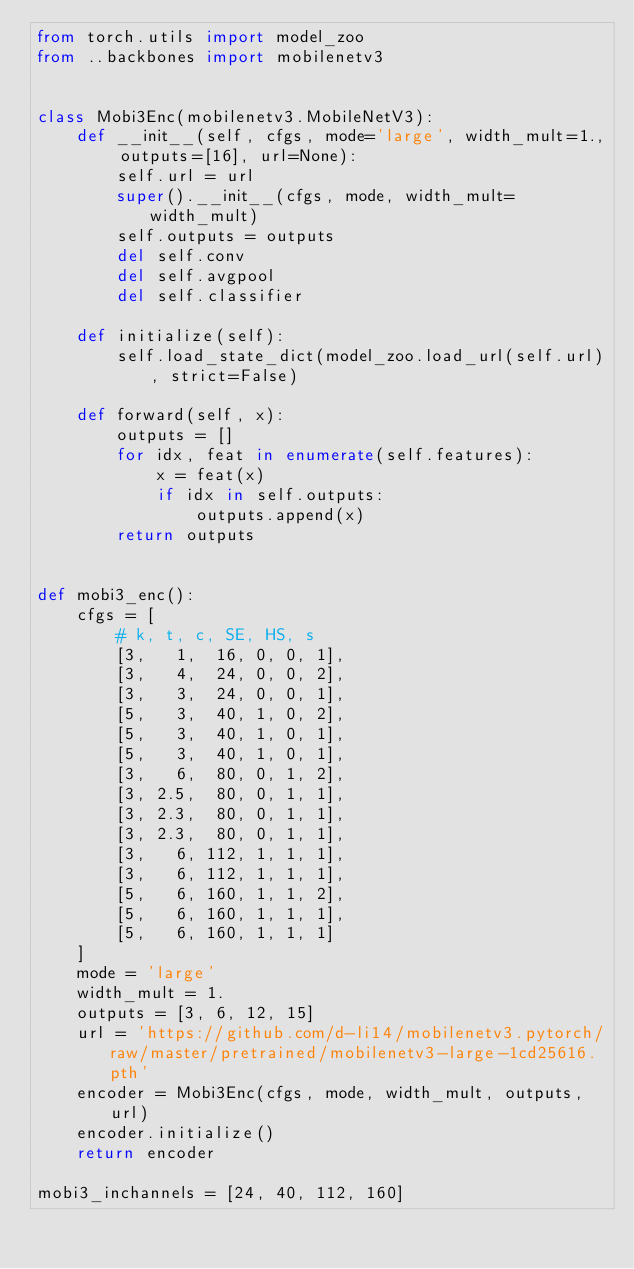Convert code to text. <code><loc_0><loc_0><loc_500><loc_500><_Python_>from torch.utils import model_zoo
from ..backbones import mobilenetv3


class Mobi3Enc(mobilenetv3.MobileNetV3):
    def __init__(self, cfgs, mode='large', width_mult=1., outputs=[16], url=None):
        self.url = url
        super().__init__(cfgs, mode, width_mult=width_mult)
        self.outputs = outputs
        del self.conv
        del self.avgpool
        del self.classifier

    def initialize(self):
        self.load_state_dict(model_zoo.load_url(self.url), strict=False)

    def forward(self, x):
        outputs = []
        for idx, feat in enumerate(self.features):
            x = feat(x)
            if idx in self.outputs:
                outputs.append(x)
        return outputs


def mobi3_enc():
    cfgs = [
        # k, t, c, SE, HS, s
        [3,   1,  16, 0, 0, 1],
        [3,   4,  24, 0, 0, 2],
        [3,   3,  24, 0, 0, 1],
        [5,   3,  40, 1, 0, 2],
        [5,   3,  40, 1, 0, 1],
        [5,   3,  40, 1, 0, 1],
        [3,   6,  80, 0, 1, 2],
        [3, 2.5,  80, 0, 1, 1],
        [3, 2.3,  80, 0, 1, 1],
        [3, 2.3,  80, 0, 1, 1],
        [3,   6, 112, 1, 1, 1],
        [3,   6, 112, 1, 1, 1],
        [5,   6, 160, 1, 1, 2],
        [5,   6, 160, 1, 1, 1],
        [5,   6, 160, 1, 1, 1]
    ]
    mode = 'large'
    width_mult = 1.
    outputs = [3, 6, 12, 15]
    url = 'https://github.com/d-li14/mobilenetv3.pytorch/raw/master/pretrained/mobilenetv3-large-1cd25616.pth'
    encoder = Mobi3Enc(cfgs, mode, width_mult, outputs, url)
    encoder.initialize()
    return encoder

mobi3_inchannels = [24, 40, 112, 160]</code> 